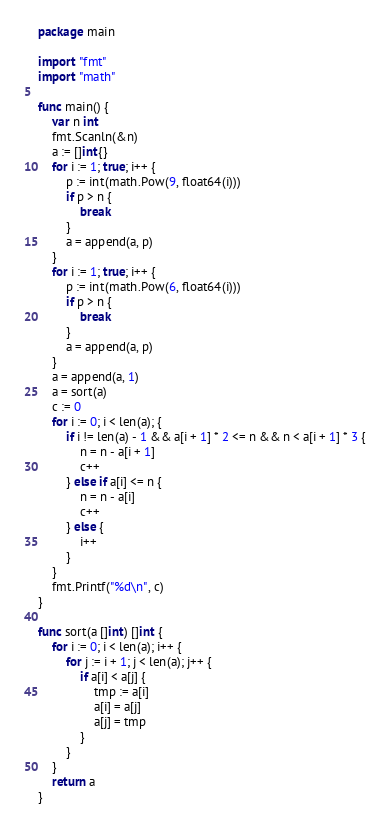<code> <loc_0><loc_0><loc_500><loc_500><_Go_>package main

import "fmt"
import "math"

func main() {
    var n int
    fmt.Scanln(&n)
    a := []int{}
    for i := 1; true; i++ {
        p := int(math.Pow(9, float64(i)))
        if p > n {
            break
        }
        a = append(a, p)
    }
    for i := 1; true; i++ {
        p := int(math.Pow(6, float64(i)))
        if p > n {
            break
        }
        a = append(a, p)
    }
    a = append(a, 1)
    a = sort(a)
    c := 0
    for i := 0; i < len(a); {
        if i != len(a) - 1 && a[i + 1] * 2 <= n && n < a[i + 1] * 3 {
            n = n - a[i + 1]
            c++
        } else if a[i] <= n {
            n = n - a[i]
            c++
        } else {
            i++
        }
    }
    fmt.Printf("%d\n", c)
}

func sort(a []int) []int {
    for i := 0; i < len(a); i++ {
        for j := i + 1; j < len(a); j++ {
            if a[i] < a[j] {
                tmp := a[i]
                a[i] = a[j]
                a[j] = tmp
            }
        }
    }
    return a
}
</code> 